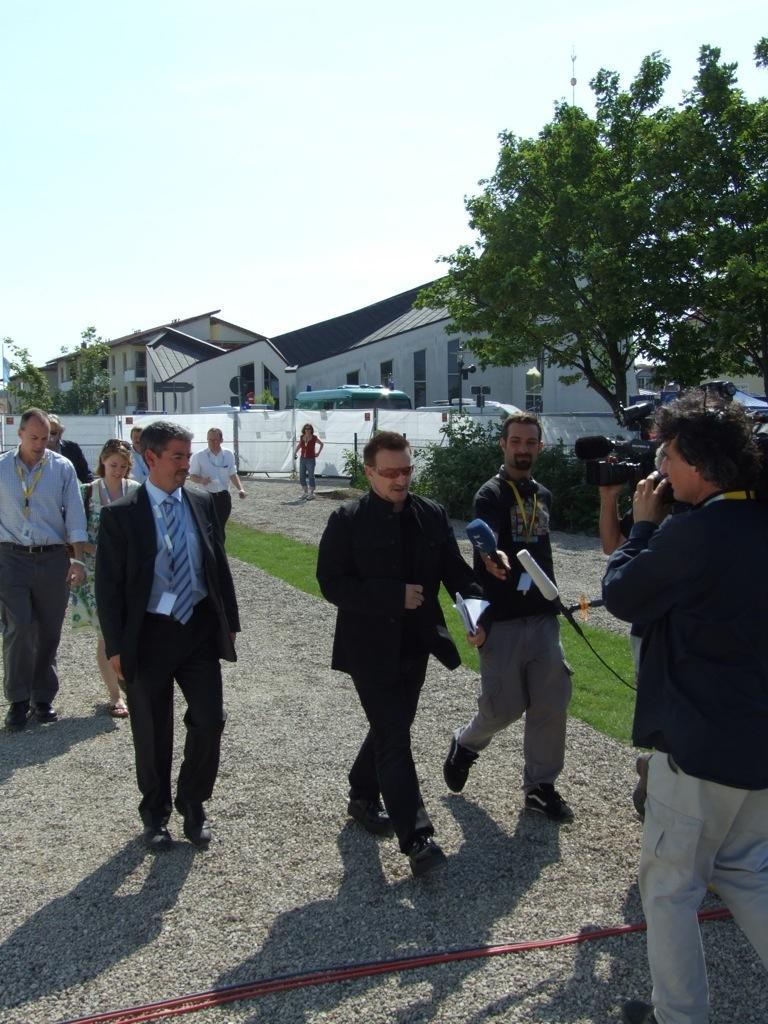Please provide a concise description of this image. In the image there are few persons standing and walking on the land, on the right side there are few persons holding cameras, in the back there are buildings with trees in front of it and above its sky. 